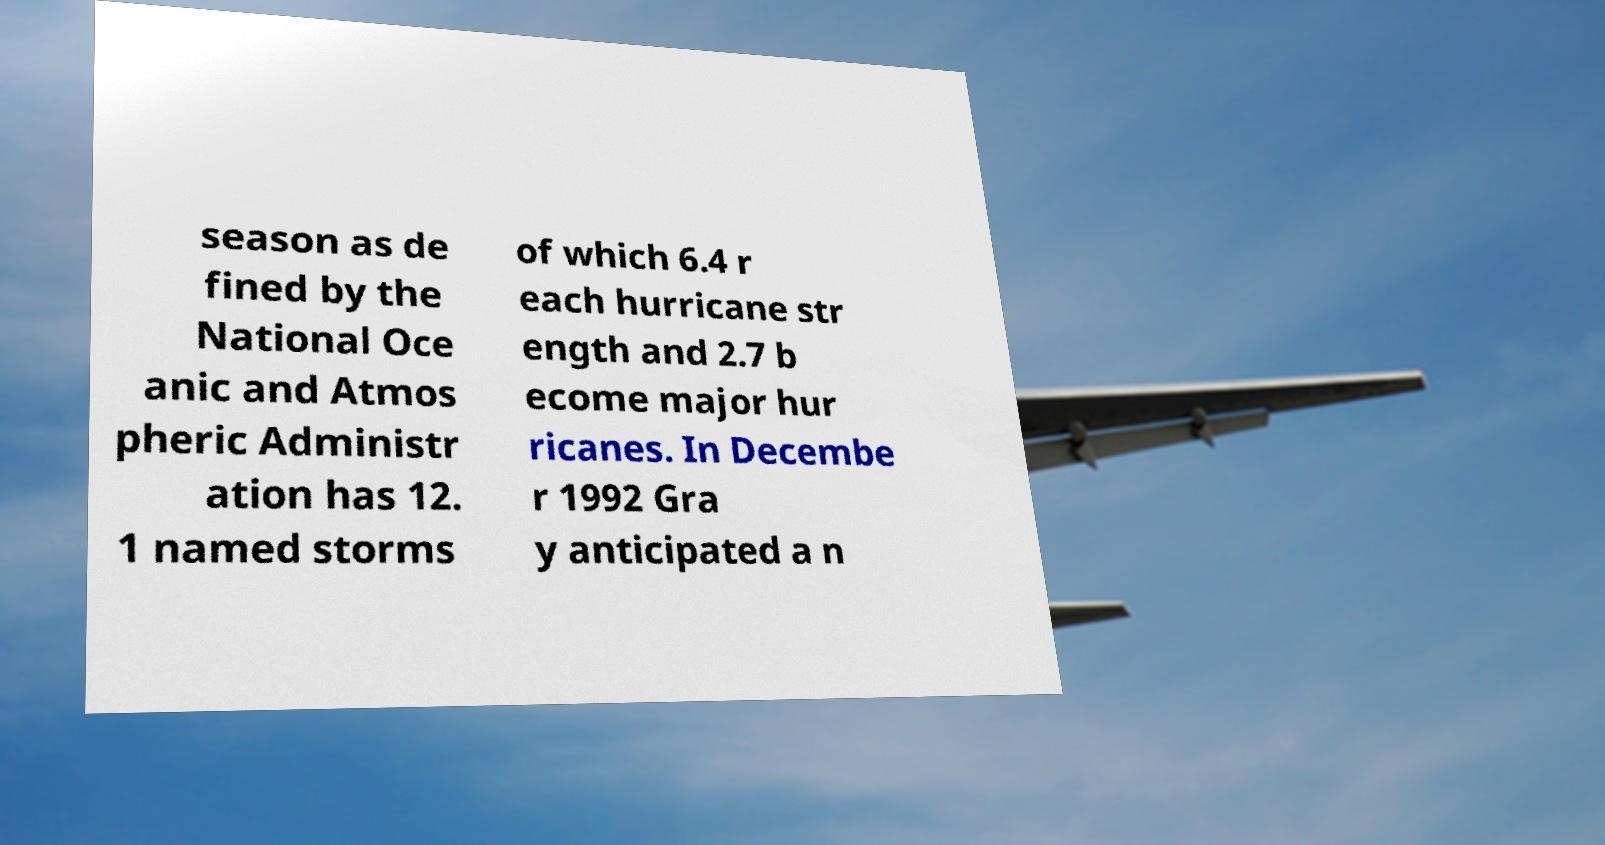Could you extract and type out the text from this image? season as de fined by the National Oce anic and Atmos pheric Administr ation has 12. 1 named storms of which 6.4 r each hurricane str ength and 2.7 b ecome major hur ricanes. In Decembe r 1992 Gra y anticipated a n 